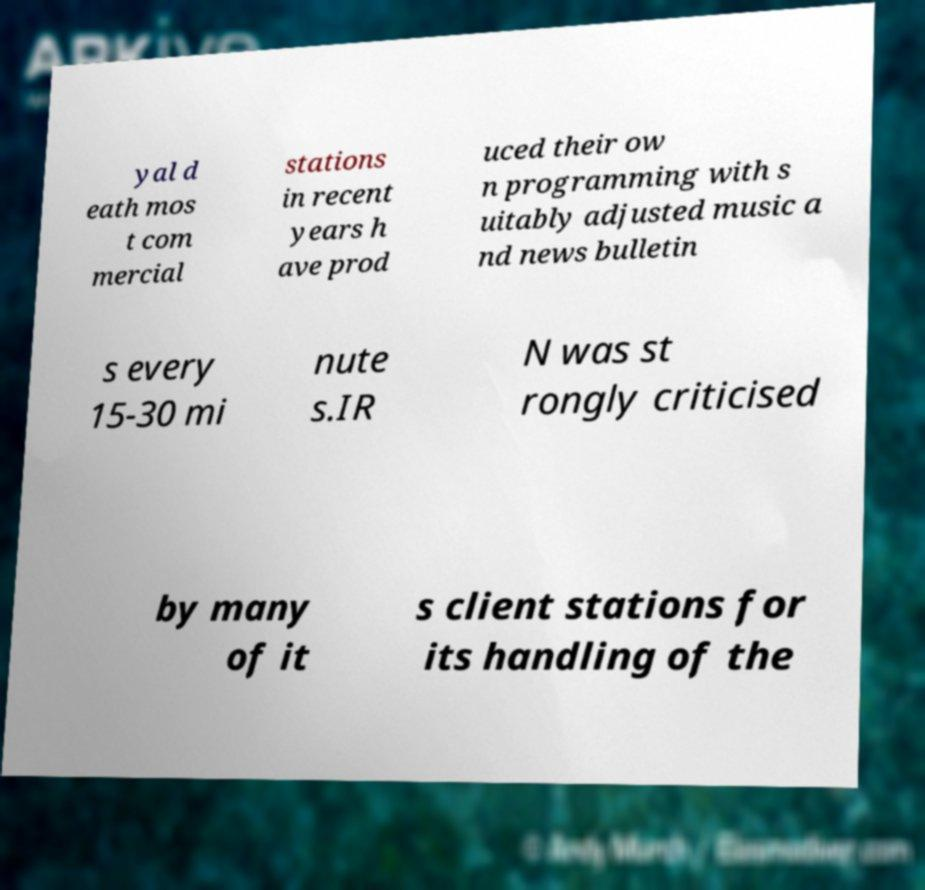Can you accurately transcribe the text from the provided image for me? yal d eath mos t com mercial stations in recent years h ave prod uced their ow n programming with s uitably adjusted music a nd news bulletin s every 15-30 mi nute s.IR N was st rongly criticised by many of it s client stations for its handling of the 